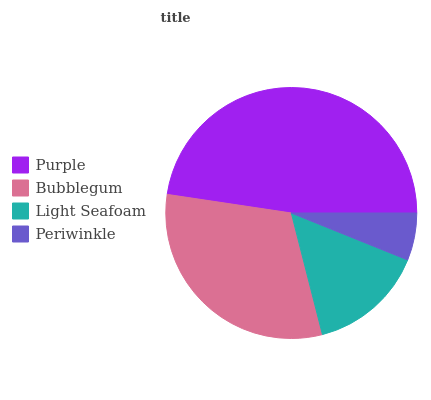Is Periwinkle the minimum?
Answer yes or no. Yes. Is Purple the maximum?
Answer yes or no. Yes. Is Bubblegum the minimum?
Answer yes or no. No. Is Bubblegum the maximum?
Answer yes or no. No. Is Purple greater than Bubblegum?
Answer yes or no. Yes. Is Bubblegum less than Purple?
Answer yes or no. Yes. Is Bubblegum greater than Purple?
Answer yes or no. No. Is Purple less than Bubblegum?
Answer yes or no. No. Is Bubblegum the high median?
Answer yes or no. Yes. Is Light Seafoam the low median?
Answer yes or no. Yes. Is Purple the high median?
Answer yes or no. No. Is Bubblegum the low median?
Answer yes or no. No. 